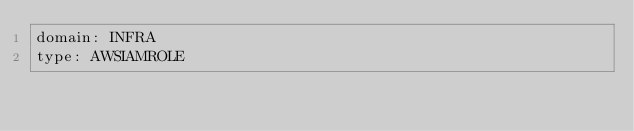Convert code to text. <code><loc_0><loc_0><loc_500><loc_500><_YAML_>domain: INFRA
type: AWSIAMROLE
</code> 